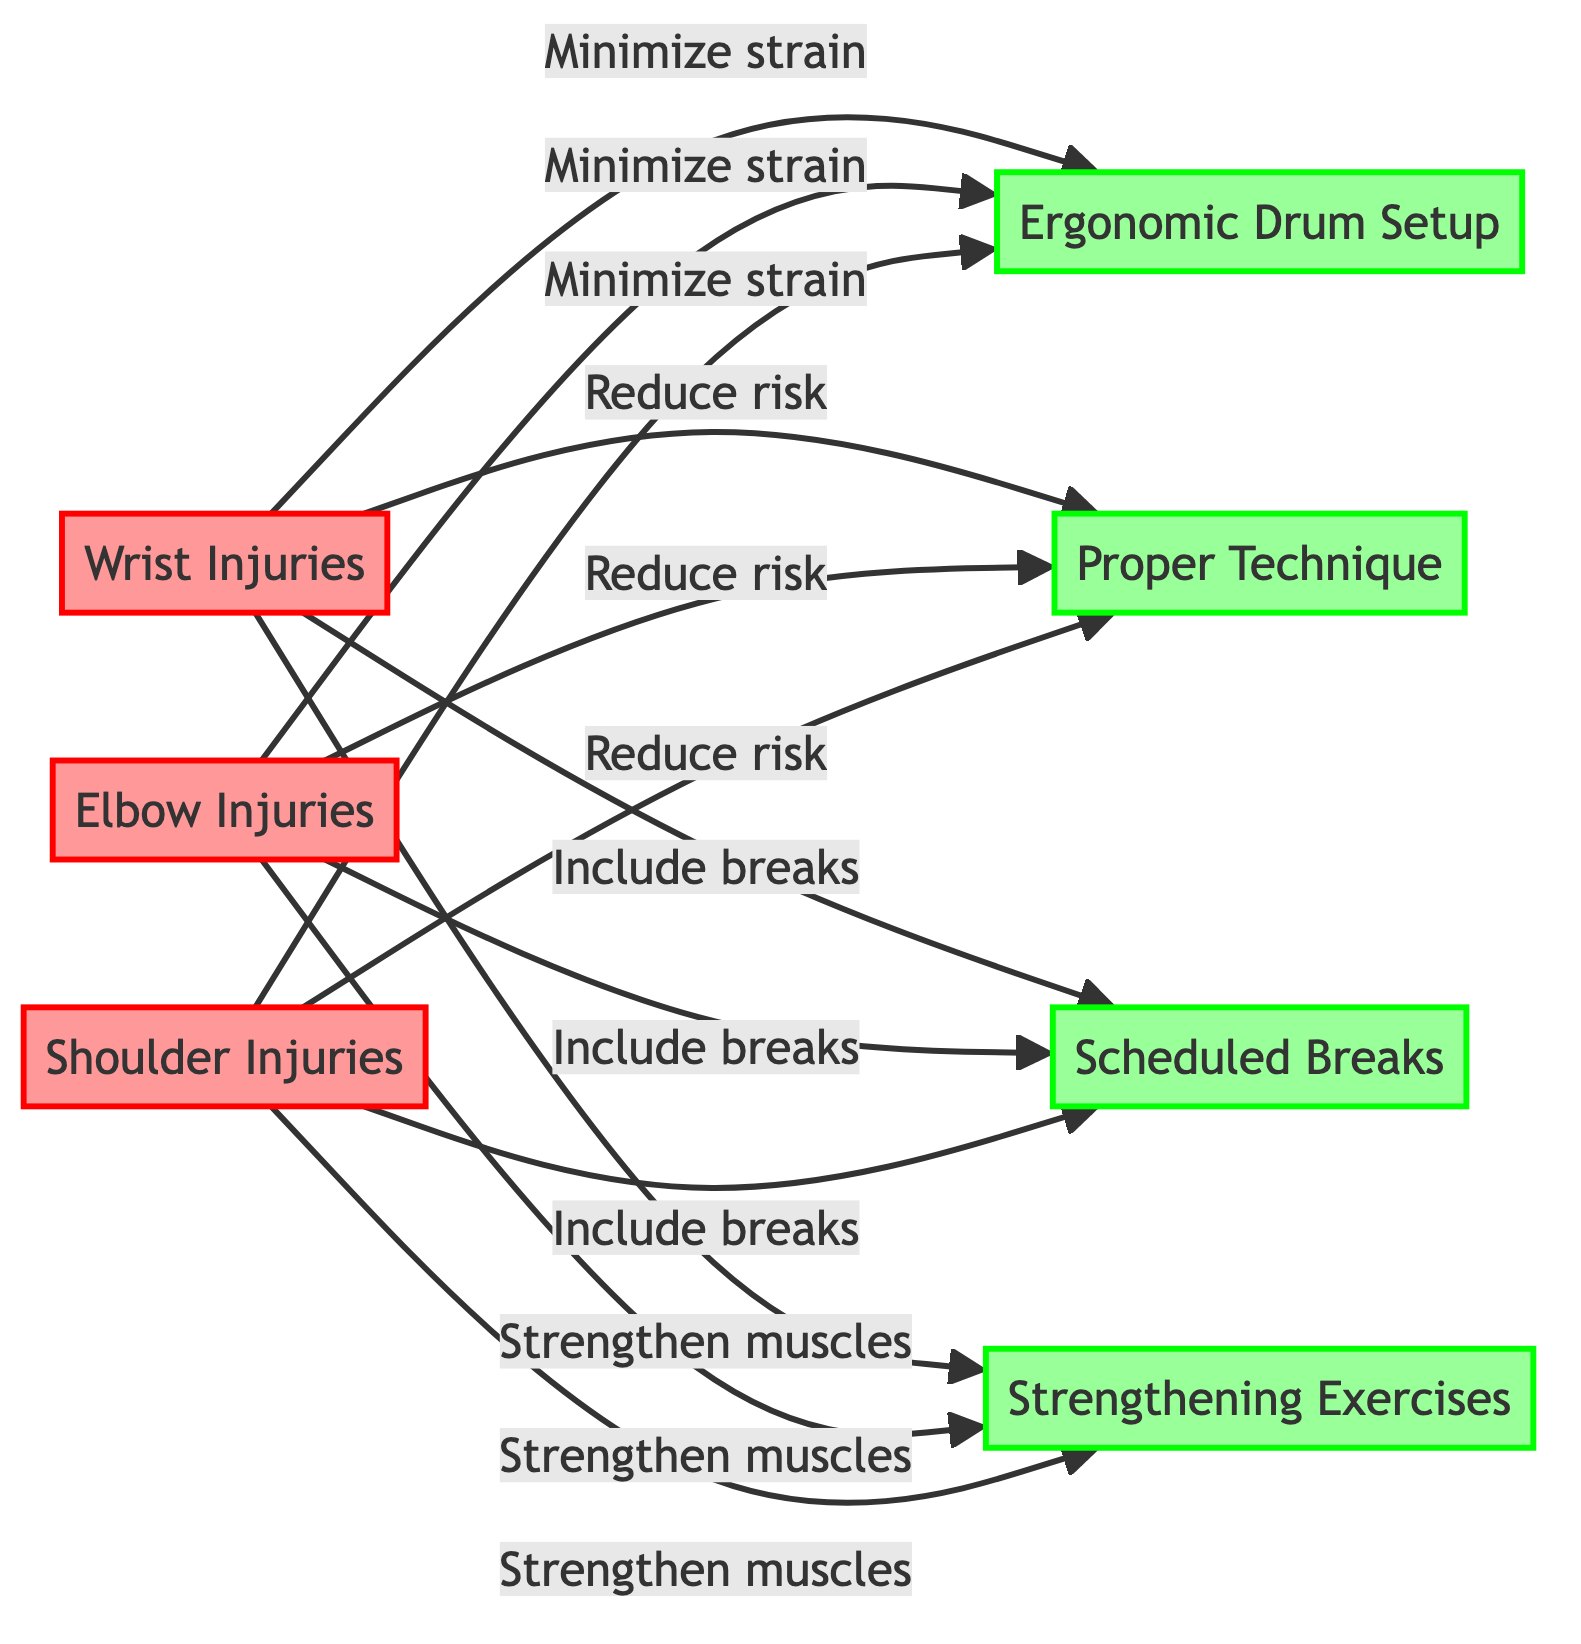What's the total number of injuries highlighted in the diagram? The diagram highlights three specific types of injuries, namely Wrist Injuries, Elbow Injuries, and Shoulder Injuries. By counting these three nodes, we find the total number of injuries is three.
Answer: 3 What is the first injury listed in the diagram? The diagram lists Wrist Injuries first, as it appears at the top among the injuries. This can be confirmed by locating the corresponding node labeled "Wrist Injuries."
Answer: Wrist Injuries Which prevention method is linked to every injury? The "Ergonomic Drum Setup" is linked to all three injuries, indicated by arrows pointing from each injury node to this prevention node. Therefore, it serves as a common preventive measure for minimizing strain for each type of injury.
Answer: Ergonomic Drum Setup How many prevention methods are shown in the diagram? The diagram includes four distinct prevention methods: Ergonomic Drum Setup, Proper Technique, Scheduled Breaks, and Strengthening Exercises. Counting these nodes provides the total number of prevention methods as four.
Answer: 4 What two injuries are directly connected to "Reduce risk"? The injuries connected to "Reduce risk" are Wrist Injuries and Elbow Injuries, shown by the arrows leading from each of these injury nodes to the prevention method node.
Answer: Wrist Injuries, Elbow Injuries What is the relationship between Elbow Injuries and Scheduled Breaks? Elbow Injuries are connected to Scheduled Breaks through an arrow which indicates that including breaks is a strategy to help reduce the risk associated with this type of injury.
Answer: Include breaks Which prevention method focuses on muscle strengthening? The prevention method focusing on muscle strengthening is "Strengthening Exercises," as indicated by a direct link from all three injury nodes to this specific node. This emphasizes the importance of strengthening as a preventive measure.
Answer: Strengthening Exercises Which injury has the least connections to prevention methods? Each injury (Wrist, Elbow, and Shoulder Injuries) has equal connections to prevention methods. Each injury is linked to all four prevention methods shown in the diagram. Therefore, no injury has fewer connections.
Answer: None What do all injuries have in common regarding prevention? All injuries share a common prevention approach of having connections to all four prevention methods indicated in the diagram. This means they are all linked to Ergonomic Drum Setup, Proper Technique, Scheduled Breaks, and Strengthening Exercises.
Answer: Minimize strain, Reduce risk, Include breaks, Strengthen muscles 